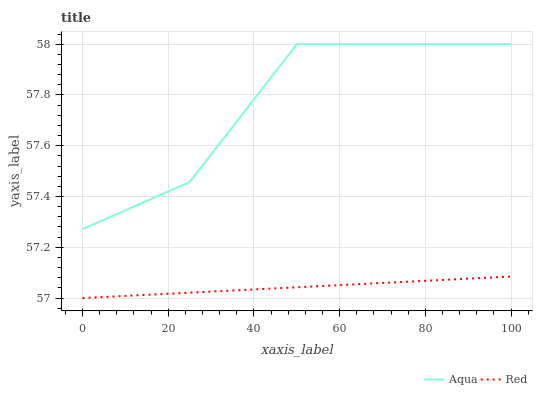Does Red have the minimum area under the curve?
Answer yes or no. Yes. Does Aqua have the maximum area under the curve?
Answer yes or no. Yes. Does Red have the maximum area under the curve?
Answer yes or no. No. Is Red the smoothest?
Answer yes or no. Yes. Is Aqua the roughest?
Answer yes or no. Yes. Is Red the roughest?
Answer yes or no. No. Does Aqua have the highest value?
Answer yes or no. Yes. Does Red have the highest value?
Answer yes or no. No. Is Red less than Aqua?
Answer yes or no. Yes. Is Aqua greater than Red?
Answer yes or no. Yes. Does Red intersect Aqua?
Answer yes or no. No. 